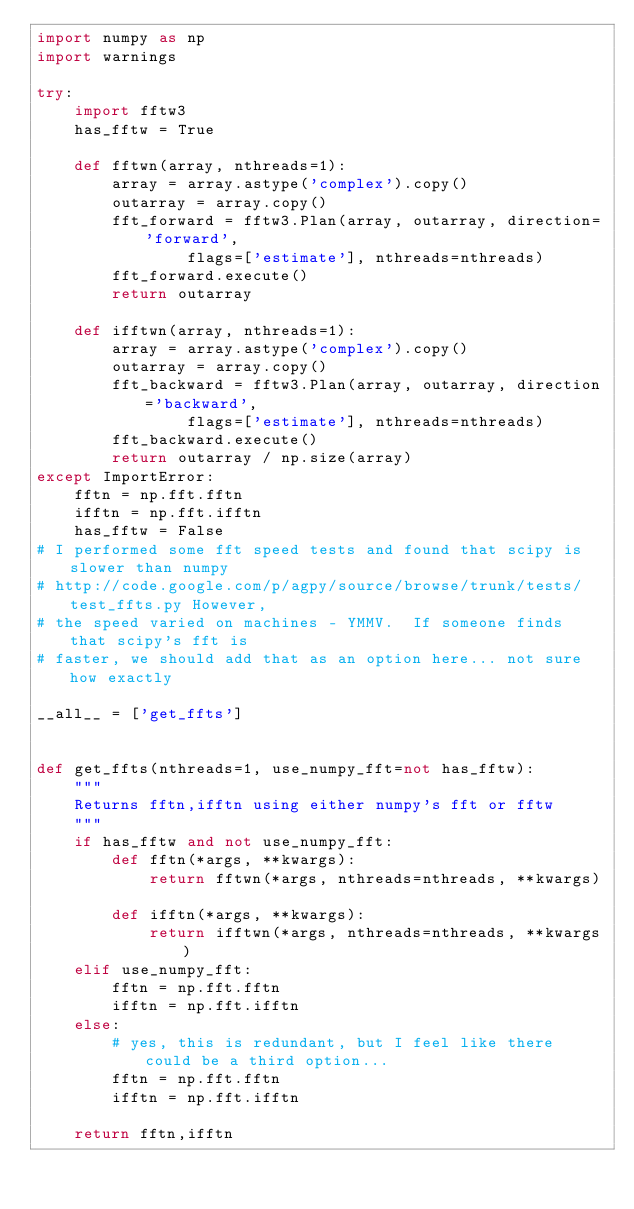Convert code to text. <code><loc_0><loc_0><loc_500><loc_500><_Python_>import numpy as np
import warnings

try:
    import fftw3
    has_fftw = True

    def fftwn(array, nthreads=1):
        array = array.astype('complex').copy()
        outarray = array.copy()
        fft_forward = fftw3.Plan(array, outarray, direction='forward',
                flags=['estimate'], nthreads=nthreads)
        fft_forward.execute()
        return outarray

    def ifftwn(array, nthreads=1):
        array = array.astype('complex').copy()
        outarray = array.copy()
        fft_backward = fftw3.Plan(array, outarray, direction='backward',
                flags=['estimate'], nthreads=nthreads)
        fft_backward.execute()
        return outarray / np.size(array)
except ImportError:
    fftn = np.fft.fftn
    ifftn = np.fft.ifftn
    has_fftw = False
# I performed some fft speed tests and found that scipy is slower than numpy
# http://code.google.com/p/agpy/source/browse/trunk/tests/test_ffts.py However,
# the speed varied on machines - YMMV.  If someone finds that scipy's fft is
# faster, we should add that as an option here... not sure how exactly

__all__ = ['get_ffts']


def get_ffts(nthreads=1, use_numpy_fft=not has_fftw):
    """
    Returns fftn,ifftn using either numpy's fft or fftw
    """
    if has_fftw and not use_numpy_fft:
        def fftn(*args, **kwargs):
            return fftwn(*args, nthreads=nthreads, **kwargs)

        def ifftn(*args, **kwargs):
            return ifftwn(*args, nthreads=nthreads, **kwargs)
    elif use_numpy_fft:
        fftn = np.fft.fftn
        ifftn = np.fft.ifftn
    else:
        # yes, this is redundant, but I feel like there could be a third option...
        fftn = np.fft.fftn
        ifftn = np.fft.ifftn

    return fftn,ifftn
</code> 